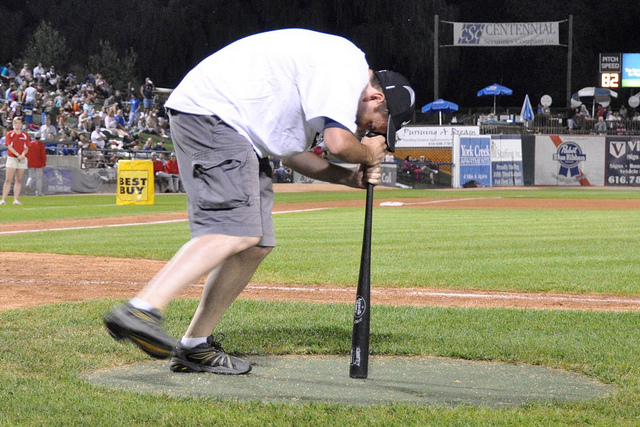Please transcribe the text information in this image. CENTENNIAL 62 616 V V BUY BEST 